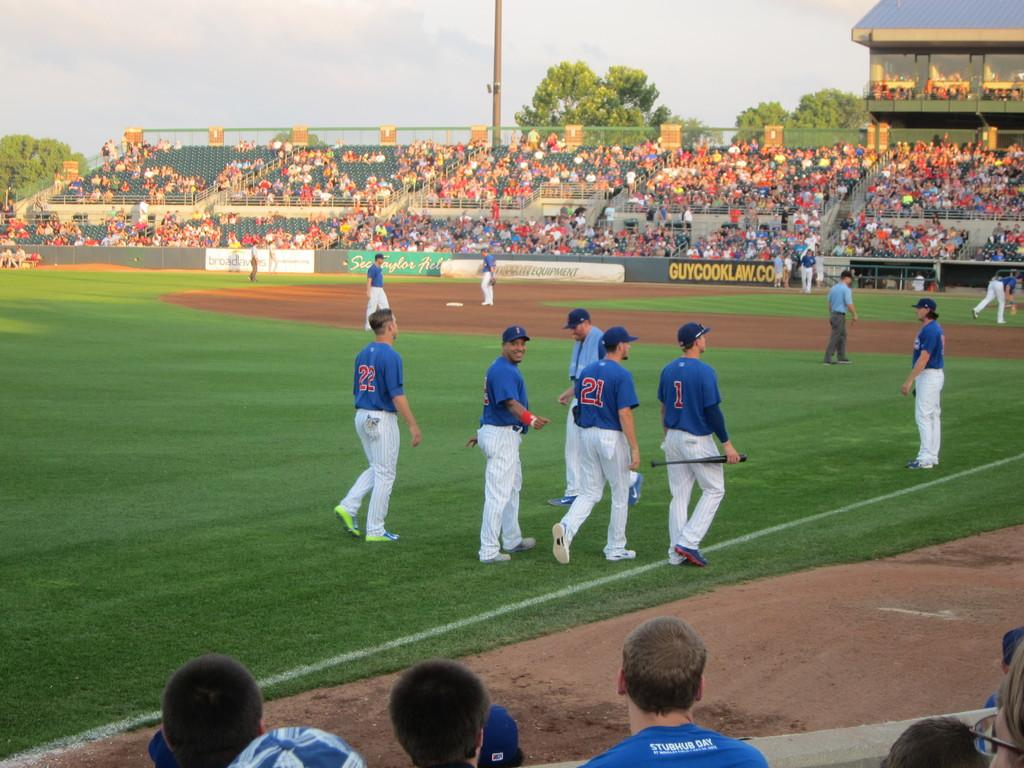<image>
Describe the image concisely. Several baseball players are standing on a field with on having the number 22 on his back. 